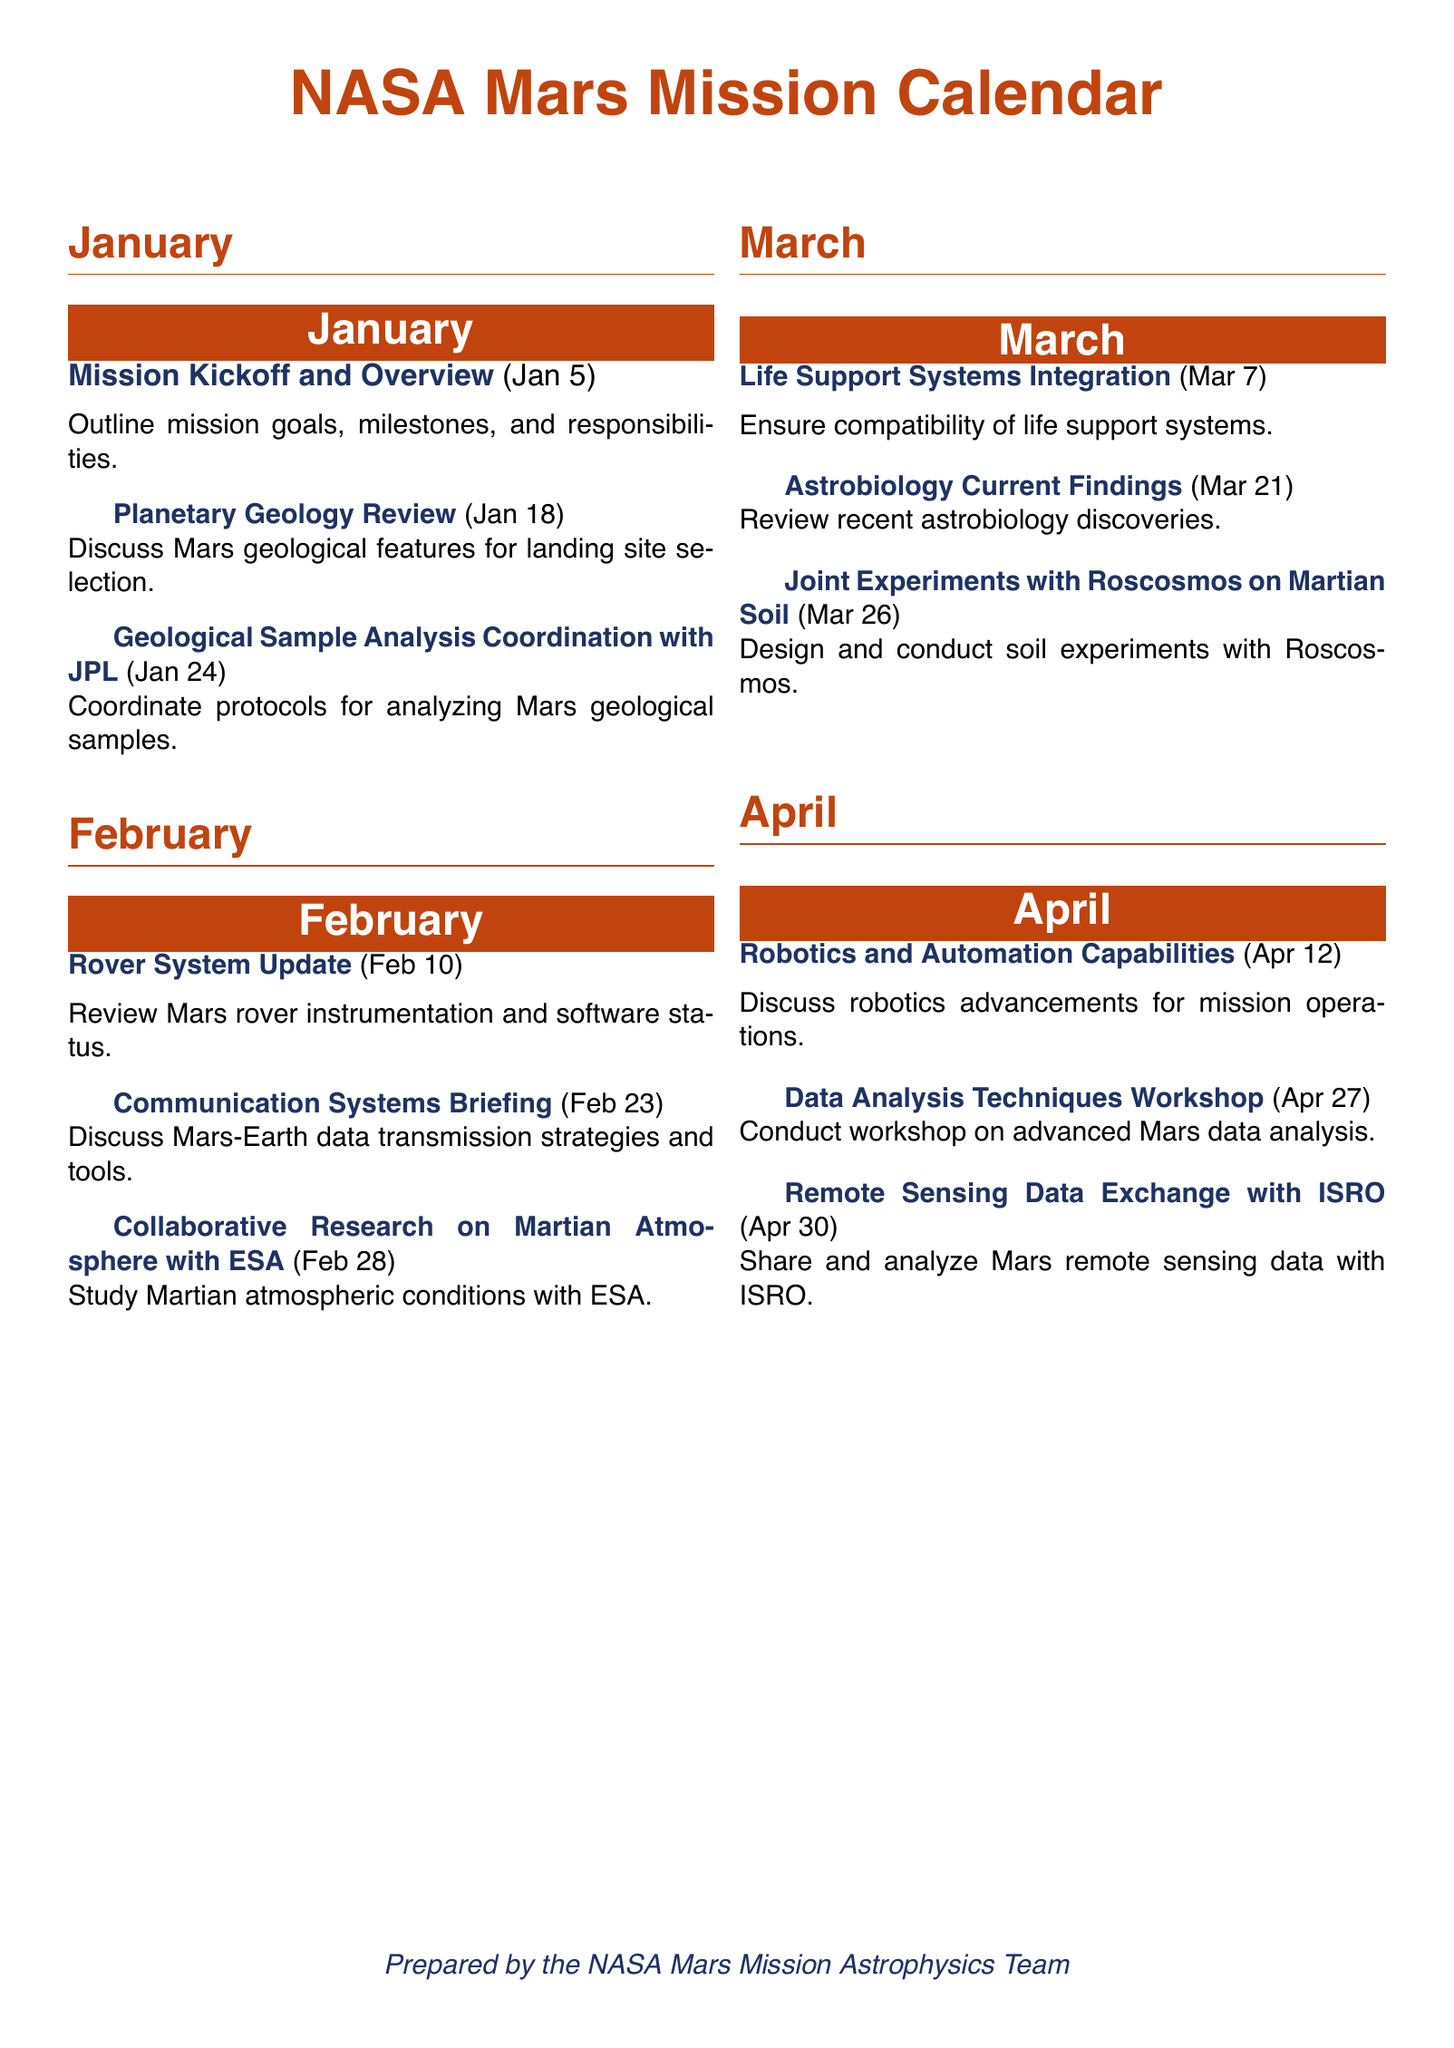What is the title of the first event in January? The first event in January is titled "Mission Kickoff and Overview."
Answer: Mission Kickoff and Overview What date is the "Collaboration Research on Martian Atmosphere with ESA" scheduled? The event is scheduled for February 28.
Answer: February 28 How many events are scheduled for April? There are three events scheduled for April.
Answer: Three Which organization is partnered for the "Joint Experiments on Martian Soil"? The partnership is with Roscosmos.
Answer: Roscosmos What is the main objective of the "Data Analysis Techniques Workshop"? The objective is to conduct a workshop on advanced Mars data analysis.
Answer: Conduct workshop on advanced Mars data analysis Which month's events include discussions about Earth-Mars communication? The discussion is scheduled for February.
Answer: February What color is used for the month headers in the document? The color used for the month headers is Mars red.
Answer: Mars red What is the purpose of the "Remote Sensing Data Exchange with ISRO"? The purpose is to share and analyze Mars remote sensing data.
Answer: Share and analyze Mars remote sensing data 